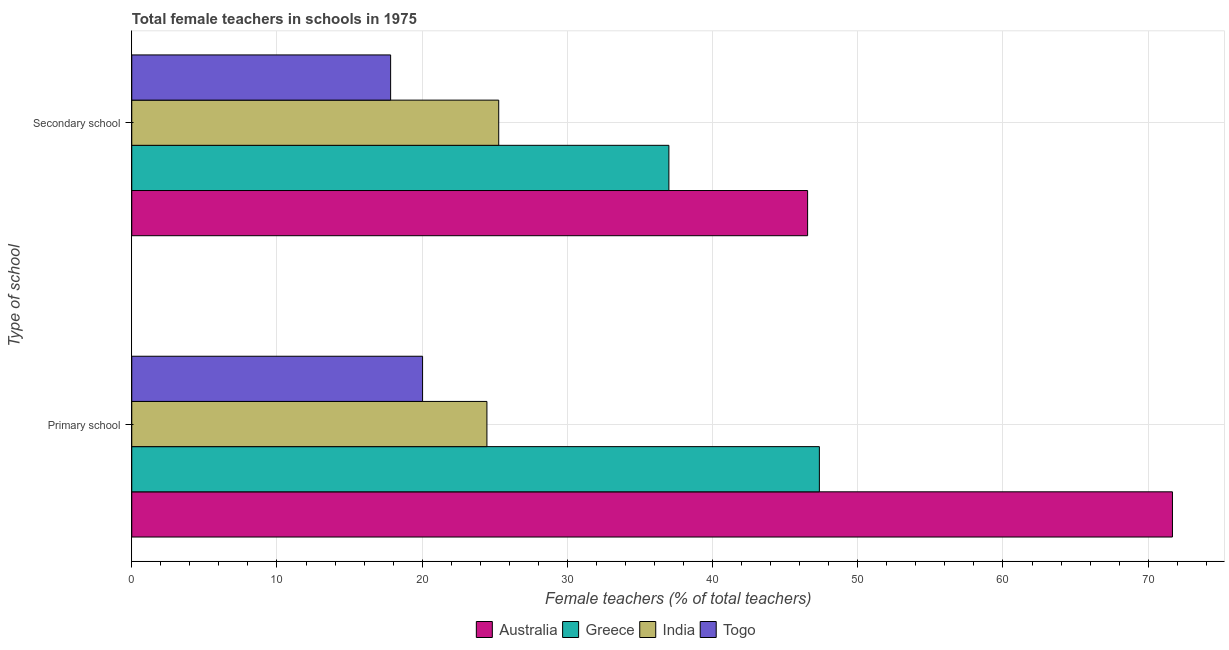Are the number of bars per tick equal to the number of legend labels?
Offer a very short reply. Yes. Are the number of bars on each tick of the Y-axis equal?
Provide a short and direct response. Yes. How many bars are there on the 2nd tick from the top?
Offer a terse response. 4. How many bars are there on the 2nd tick from the bottom?
Provide a succinct answer. 4. What is the label of the 2nd group of bars from the top?
Your answer should be compact. Primary school. What is the percentage of female teachers in primary schools in Australia?
Your answer should be very brief. 71.67. Across all countries, what is the maximum percentage of female teachers in secondary schools?
Your answer should be compact. 46.55. Across all countries, what is the minimum percentage of female teachers in secondary schools?
Your response must be concise. 17.83. In which country was the percentage of female teachers in secondary schools minimum?
Give a very brief answer. Togo. What is the total percentage of female teachers in primary schools in the graph?
Your answer should be very brief. 163.52. What is the difference between the percentage of female teachers in primary schools in Greece and that in Togo?
Provide a succinct answer. 27.33. What is the difference between the percentage of female teachers in secondary schools in Greece and the percentage of female teachers in primary schools in India?
Your response must be concise. 12.53. What is the average percentage of female teachers in primary schools per country?
Give a very brief answer. 40.88. What is the difference between the percentage of female teachers in secondary schools and percentage of female teachers in primary schools in Togo?
Offer a very short reply. -2.2. What is the ratio of the percentage of female teachers in secondary schools in India to that in Greece?
Your response must be concise. 0.68. What does the 1st bar from the top in Secondary school represents?
Make the answer very short. Togo. How many bars are there?
Ensure brevity in your answer.  8. Are all the bars in the graph horizontal?
Provide a short and direct response. Yes. How many countries are there in the graph?
Your answer should be compact. 4. What is the difference between two consecutive major ticks on the X-axis?
Your answer should be very brief. 10. Are the values on the major ticks of X-axis written in scientific E-notation?
Your answer should be compact. No. Does the graph contain any zero values?
Ensure brevity in your answer.  No. Where does the legend appear in the graph?
Your answer should be compact. Bottom center. How are the legend labels stacked?
Your answer should be compact. Horizontal. What is the title of the graph?
Provide a short and direct response. Total female teachers in schools in 1975. Does "China" appear as one of the legend labels in the graph?
Offer a very short reply. No. What is the label or title of the X-axis?
Ensure brevity in your answer.  Female teachers (% of total teachers). What is the label or title of the Y-axis?
Your answer should be very brief. Type of school. What is the Female teachers (% of total teachers) of Australia in Primary school?
Make the answer very short. 71.67. What is the Female teachers (% of total teachers) of Greece in Primary school?
Your response must be concise. 47.36. What is the Female teachers (% of total teachers) in India in Primary school?
Your answer should be very brief. 24.46. What is the Female teachers (% of total teachers) of Togo in Primary school?
Make the answer very short. 20.03. What is the Female teachers (% of total teachers) of Australia in Secondary school?
Provide a succinct answer. 46.55. What is the Female teachers (% of total teachers) of Greece in Secondary school?
Your response must be concise. 36.99. What is the Female teachers (% of total teachers) in India in Secondary school?
Your response must be concise. 25.27. What is the Female teachers (% of total teachers) of Togo in Secondary school?
Your answer should be compact. 17.83. Across all Type of school, what is the maximum Female teachers (% of total teachers) of Australia?
Keep it short and to the point. 71.67. Across all Type of school, what is the maximum Female teachers (% of total teachers) of Greece?
Offer a terse response. 47.36. Across all Type of school, what is the maximum Female teachers (% of total teachers) of India?
Your answer should be very brief. 25.27. Across all Type of school, what is the maximum Female teachers (% of total teachers) of Togo?
Make the answer very short. 20.03. Across all Type of school, what is the minimum Female teachers (% of total teachers) in Australia?
Ensure brevity in your answer.  46.55. Across all Type of school, what is the minimum Female teachers (% of total teachers) of Greece?
Your answer should be very brief. 36.99. Across all Type of school, what is the minimum Female teachers (% of total teachers) of India?
Provide a short and direct response. 24.46. Across all Type of school, what is the minimum Female teachers (% of total teachers) of Togo?
Your answer should be very brief. 17.83. What is the total Female teachers (% of total teachers) of Australia in the graph?
Offer a very short reply. 118.22. What is the total Female teachers (% of total teachers) in Greece in the graph?
Offer a terse response. 84.35. What is the total Female teachers (% of total teachers) in India in the graph?
Ensure brevity in your answer.  49.73. What is the total Female teachers (% of total teachers) of Togo in the graph?
Your answer should be compact. 37.86. What is the difference between the Female teachers (% of total teachers) in Australia in Primary school and that in Secondary school?
Provide a short and direct response. 25.13. What is the difference between the Female teachers (% of total teachers) in Greece in Primary school and that in Secondary school?
Your answer should be very brief. 10.36. What is the difference between the Female teachers (% of total teachers) of India in Primary school and that in Secondary school?
Offer a terse response. -0.81. What is the difference between the Female teachers (% of total teachers) in Togo in Primary school and that in Secondary school?
Provide a succinct answer. 2.2. What is the difference between the Female teachers (% of total teachers) of Australia in Primary school and the Female teachers (% of total teachers) of Greece in Secondary school?
Offer a terse response. 34.68. What is the difference between the Female teachers (% of total teachers) in Australia in Primary school and the Female teachers (% of total teachers) in India in Secondary school?
Your answer should be compact. 46.4. What is the difference between the Female teachers (% of total teachers) of Australia in Primary school and the Female teachers (% of total teachers) of Togo in Secondary school?
Provide a short and direct response. 53.85. What is the difference between the Female teachers (% of total teachers) in Greece in Primary school and the Female teachers (% of total teachers) in India in Secondary school?
Ensure brevity in your answer.  22.08. What is the difference between the Female teachers (% of total teachers) in Greece in Primary school and the Female teachers (% of total teachers) in Togo in Secondary school?
Provide a succinct answer. 29.53. What is the difference between the Female teachers (% of total teachers) of India in Primary school and the Female teachers (% of total teachers) of Togo in Secondary school?
Offer a very short reply. 6.63. What is the average Female teachers (% of total teachers) in Australia per Type of school?
Make the answer very short. 59.11. What is the average Female teachers (% of total teachers) in Greece per Type of school?
Provide a short and direct response. 42.17. What is the average Female teachers (% of total teachers) in India per Type of school?
Provide a succinct answer. 24.87. What is the average Female teachers (% of total teachers) of Togo per Type of school?
Provide a short and direct response. 18.93. What is the difference between the Female teachers (% of total teachers) of Australia and Female teachers (% of total teachers) of Greece in Primary school?
Your answer should be compact. 24.32. What is the difference between the Female teachers (% of total teachers) of Australia and Female teachers (% of total teachers) of India in Primary school?
Your response must be concise. 47.21. What is the difference between the Female teachers (% of total teachers) of Australia and Female teachers (% of total teachers) of Togo in Primary school?
Your answer should be compact. 51.65. What is the difference between the Female teachers (% of total teachers) of Greece and Female teachers (% of total teachers) of India in Primary school?
Your answer should be compact. 22.9. What is the difference between the Female teachers (% of total teachers) in Greece and Female teachers (% of total teachers) in Togo in Primary school?
Make the answer very short. 27.33. What is the difference between the Female teachers (% of total teachers) in India and Female teachers (% of total teachers) in Togo in Primary school?
Offer a very short reply. 4.43. What is the difference between the Female teachers (% of total teachers) of Australia and Female teachers (% of total teachers) of Greece in Secondary school?
Your answer should be compact. 9.55. What is the difference between the Female teachers (% of total teachers) of Australia and Female teachers (% of total teachers) of India in Secondary school?
Offer a terse response. 21.27. What is the difference between the Female teachers (% of total teachers) of Australia and Female teachers (% of total teachers) of Togo in Secondary school?
Provide a succinct answer. 28.72. What is the difference between the Female teachers (% of total teachers) in Greece and Female teachers (% of total teachers) in India in Secondary school?
Provide a short and direct response. 11.72. What is the difference between the Female teachers (% of total teachers) of Greece and Female teachers (% of total teachers) of Togo in Secondary school?
Your answer should be compact. 19.16. What is the difference between the Female teachers (% of total teachers) of India and Female teachers (% of total teachers) of Togo in Secondary school?
Offer a terse response. 7.44. What is the ratio of the Female teachers (% of total teachers) of Australia in Primary school to that in Secondary school?
Your response must be concise. 1.54. What is the ratio of the Female teachers (% of total teachers) of Greece in Primary school to that in Secondary school?
Offer a terse response. 1.28. What is the ratio of the Female teachers (% of total teachers) of India in Primary school to that in Secondary school?
Offer a terse response. 0.97. What is the ratio of the Female teachers (% of total teachers) of Togo in Primary school to that in Secondary school?
Offer a terse response. 1.12. What is the difference between the highest and the second highest Female teachers (% of total teachers) in Australia?
Keep it short and to the point. 25.13. What is the difference between the highest and the second highest Female teachers (% of total teachers) in Greece?
Give a very brief answer. 10.36. What is the difference between the highest and the second highest Female teachers (% of total teachers) in India?
Offer a very short reply. 0.81. What is the difference between the highest and the second highest Female teachers (% of total teachers) in Togo?
Your answer should be compact. 2.2. What is the difference between the highest and the lowest Female teachers (% of total teachers) of Australia?
Ensure brevity in your answer.  25.13. What is the difference between the highest and the lowest Female teachers (% of total teachers) in Greece?
Keep it short and to the point. 10.36. What is the difference between the highest and the lowest Female teachers (% of total teachers) of India?
Your answer should be compact. 0.81. What is the difference between the highest and the lowest Female teachers (% of total teachers) in Togo?
Offer a very short reply. 2.2. 